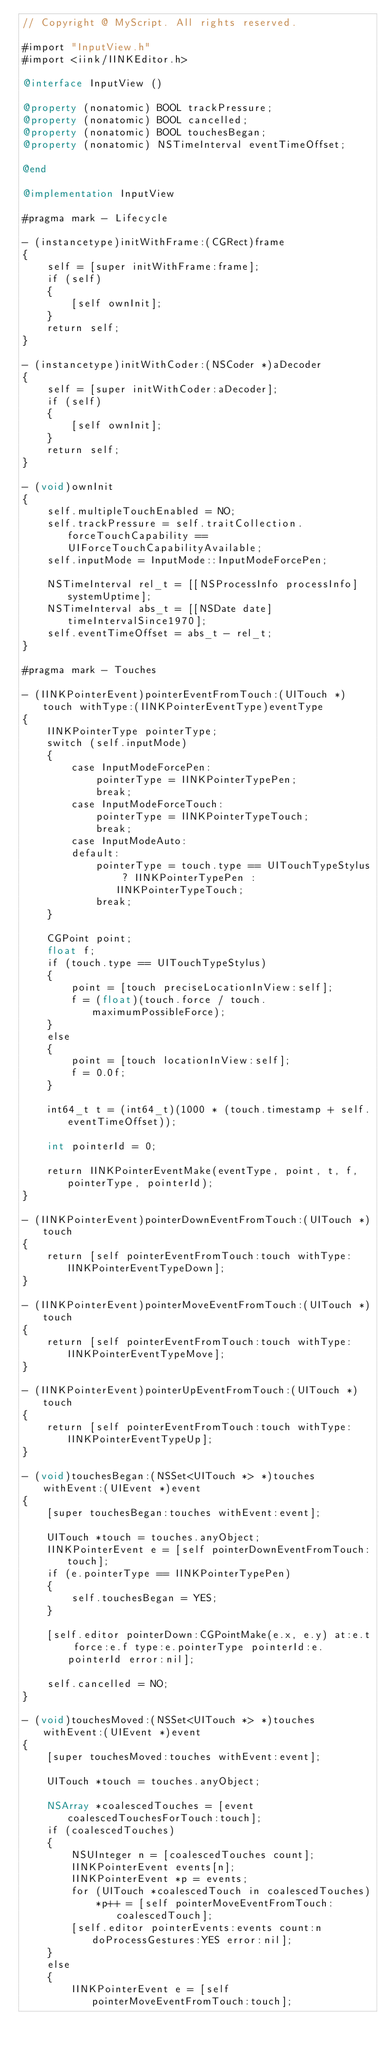<code> <loc_0><loc_0><loc_500><loc_500><_ObjectiveC_>// Copyright @ MyScript. All rights reserved.

#import "InputView.h"
#import <iink/IINKEditor.h>

@interface InputView ()

@property (nonatomic) BOOL trackPressure;
@property (nonatomic) BOOL cancelled;
@property (nonatomic) BOOL touchesBegan;
@property (nonatomic) NSTimeInterval eventTimeOffset;

@end

@implementation InputView

#pragma mark - Lifecycle

- (instancetype)initWithFrame:(CGRect)frame
{
    self = [super initWithFrame:frame];
    if (self)
    {
        [self ownInit];
    }
    return self;
}

- (instancetype)initWithCoder:(NSCoder *)aDecoder
{
    self = [super initWithCoder:aDecoder];
    if (self)
    {
        [self ownInit];
    }
    return self;
}

- (void)ownInit
{
    self.multipleTouchEnabled = NO;
    self.trackPressure = self.traitCollection.forceTouchCapability == UIForceTouchCapabilityAvailable;
    self.inputMode = InputMode::InputModeForcePen;

    NSTimeInterval rel_t = [[NSProcessInfo processInfo] systemUptime];
    NSTimeInterval abs_t = [[NSDate date] timeIntervalSince1970];
    self.eventTimeOffset = abs_t - rel_t;
}

#pragma mark - Touches

- (IINKPointerEvent)pointerEventFromTouch:(UITouch *)touch withType:(IINKPointerEventType)eventType
{
    IINKPointerType pointerType;
    switch (self.inputMode)
    {
        case InputModeForcePen:
            pointerType = IINKPointerTypePen;
            break;
        case InputModeForceTouch:
            pointerType = IINKPointerTypeTouch;
            break;
        case InputModeAuto:
        default:
            pointerType = touch.type == UITouchTypeStylus ? IINKPointerTypePen : IINKPointerTypeTouch;
            break;
    }

    CGPoint point;
    float f;
    if (touch.type == UITouchTypeStylus)
    {
        point = [touch preciseLocationInView:self];
        f = (float)(touch.force / touch.maximumPossibleForce);
    }
    else
    {
        point = [touch locationInView:self];
        f = 0.0f;
    }

    int64_t t = (int64_t)(1000 * (touch.timestamp + self.eventTimeOffset));

    int pointerId = 0;

    return IINKPointerEventMake(eventType, point, t, f, pointerType, pointerId);
}

- (IINKPointerEvent)pointerDownEventFromTouch:(UITouch *)touch
{
    return [self pointerEventFromTouch:touch withType:IINKPointerEventTypeDown];
}

- (IINKPointerEvent)pointerMoveEventFromTouch:(UITouch *)touch
{
    return [self pointerEventFromTouch:touch withType:IINKPointerEventTypeMove];
}

- (IINKPointerEvent)pointerUpEventFromTouch:(UITouch *)touch
{
    return [self pointerEventFromTouch:touch withType:IINKPointerEventTypeUp];
}

- (void)touchesBegan:(NSSet<UITouch *> *)touches withEvent:(UIEvent *)event
{
    [super touchesBegan:touches withEvent:event];
    
    UITouch *touch = touches.anyObject;
    IINKPointerEvent e = [self pointerDownEventFromTouch:touch];
    if (e.pointerType == IINKPointerTypePen)
    {
        self.touchesBegan = YES;
    }
    
    [self.editor pointerDown:CGPointMake(e.x, e.y) at:e.t force:e.f type:e.pointerType pointerId:e.pointerId error:nil];
    
    self.cancelled = NO;
}

- (void)touchesMoved:(NSSet<UITouch *> *)touches withEvent:(UIEvent *)event
{
    [super touchesMoved:touches withEvent:event];
    
    UITouch *touch = touches.anyObject;
    
    NSArray *coalescedTouches = [event coalescedTouchesForTouch:touch];
    if (coalescedTouches)
    {
        NSUInteger n = [coalescedTouches count];
        IINKPointerEvent events[n];
        IINKPointerEvent *p = events;
        for (UITouch *coalescedTouch in coalescedTouches)
            *p++ = [self pointerMoveEventFromTouch:coalescedTouch];
        [self.editor pointerEvents:events count:n doProcessGestures:YES error:nil];
    }
    else
    {
        IINKPointerEvent e = [self pointerMoveEventFromTouch:touch];</code> 